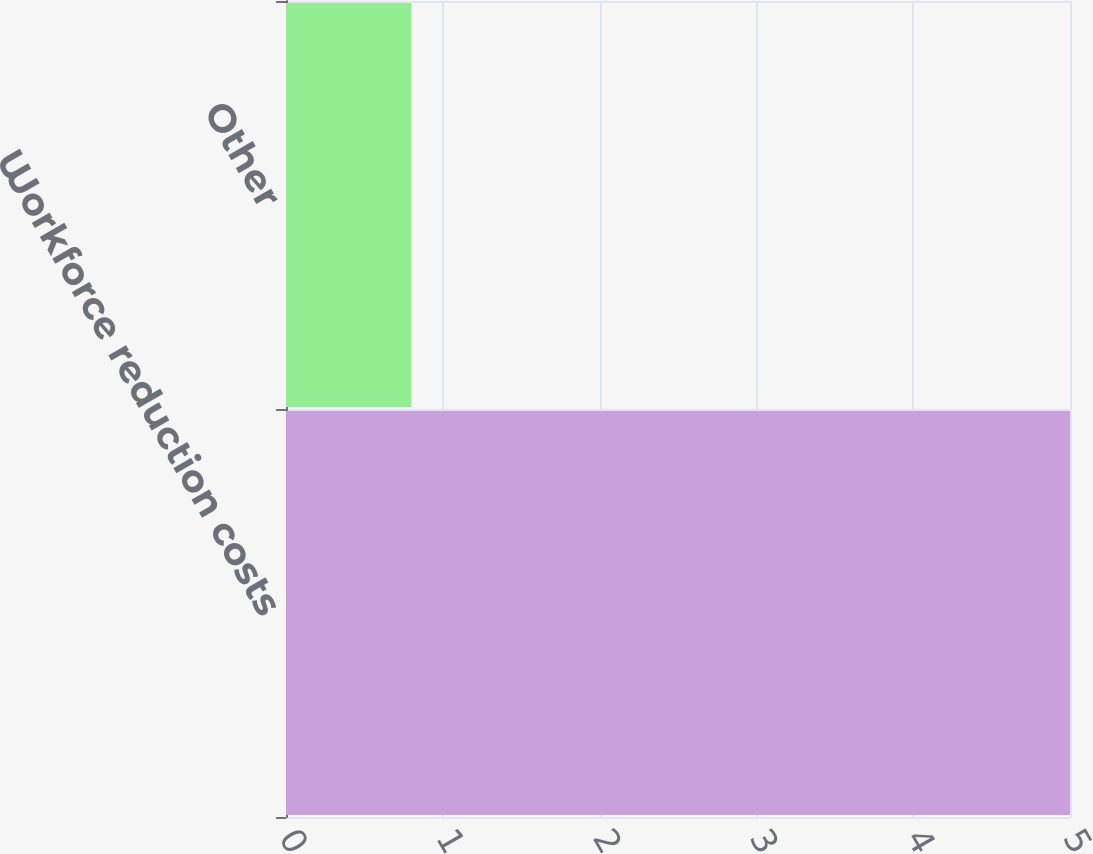Convert chart. <chart><loc_0><loc_0><loc_500><loc_500><bar_chart><fcel>Workforce reduction costs<fcel>Other<nl><fcel>5<fcel>0.8<nl></chart> 